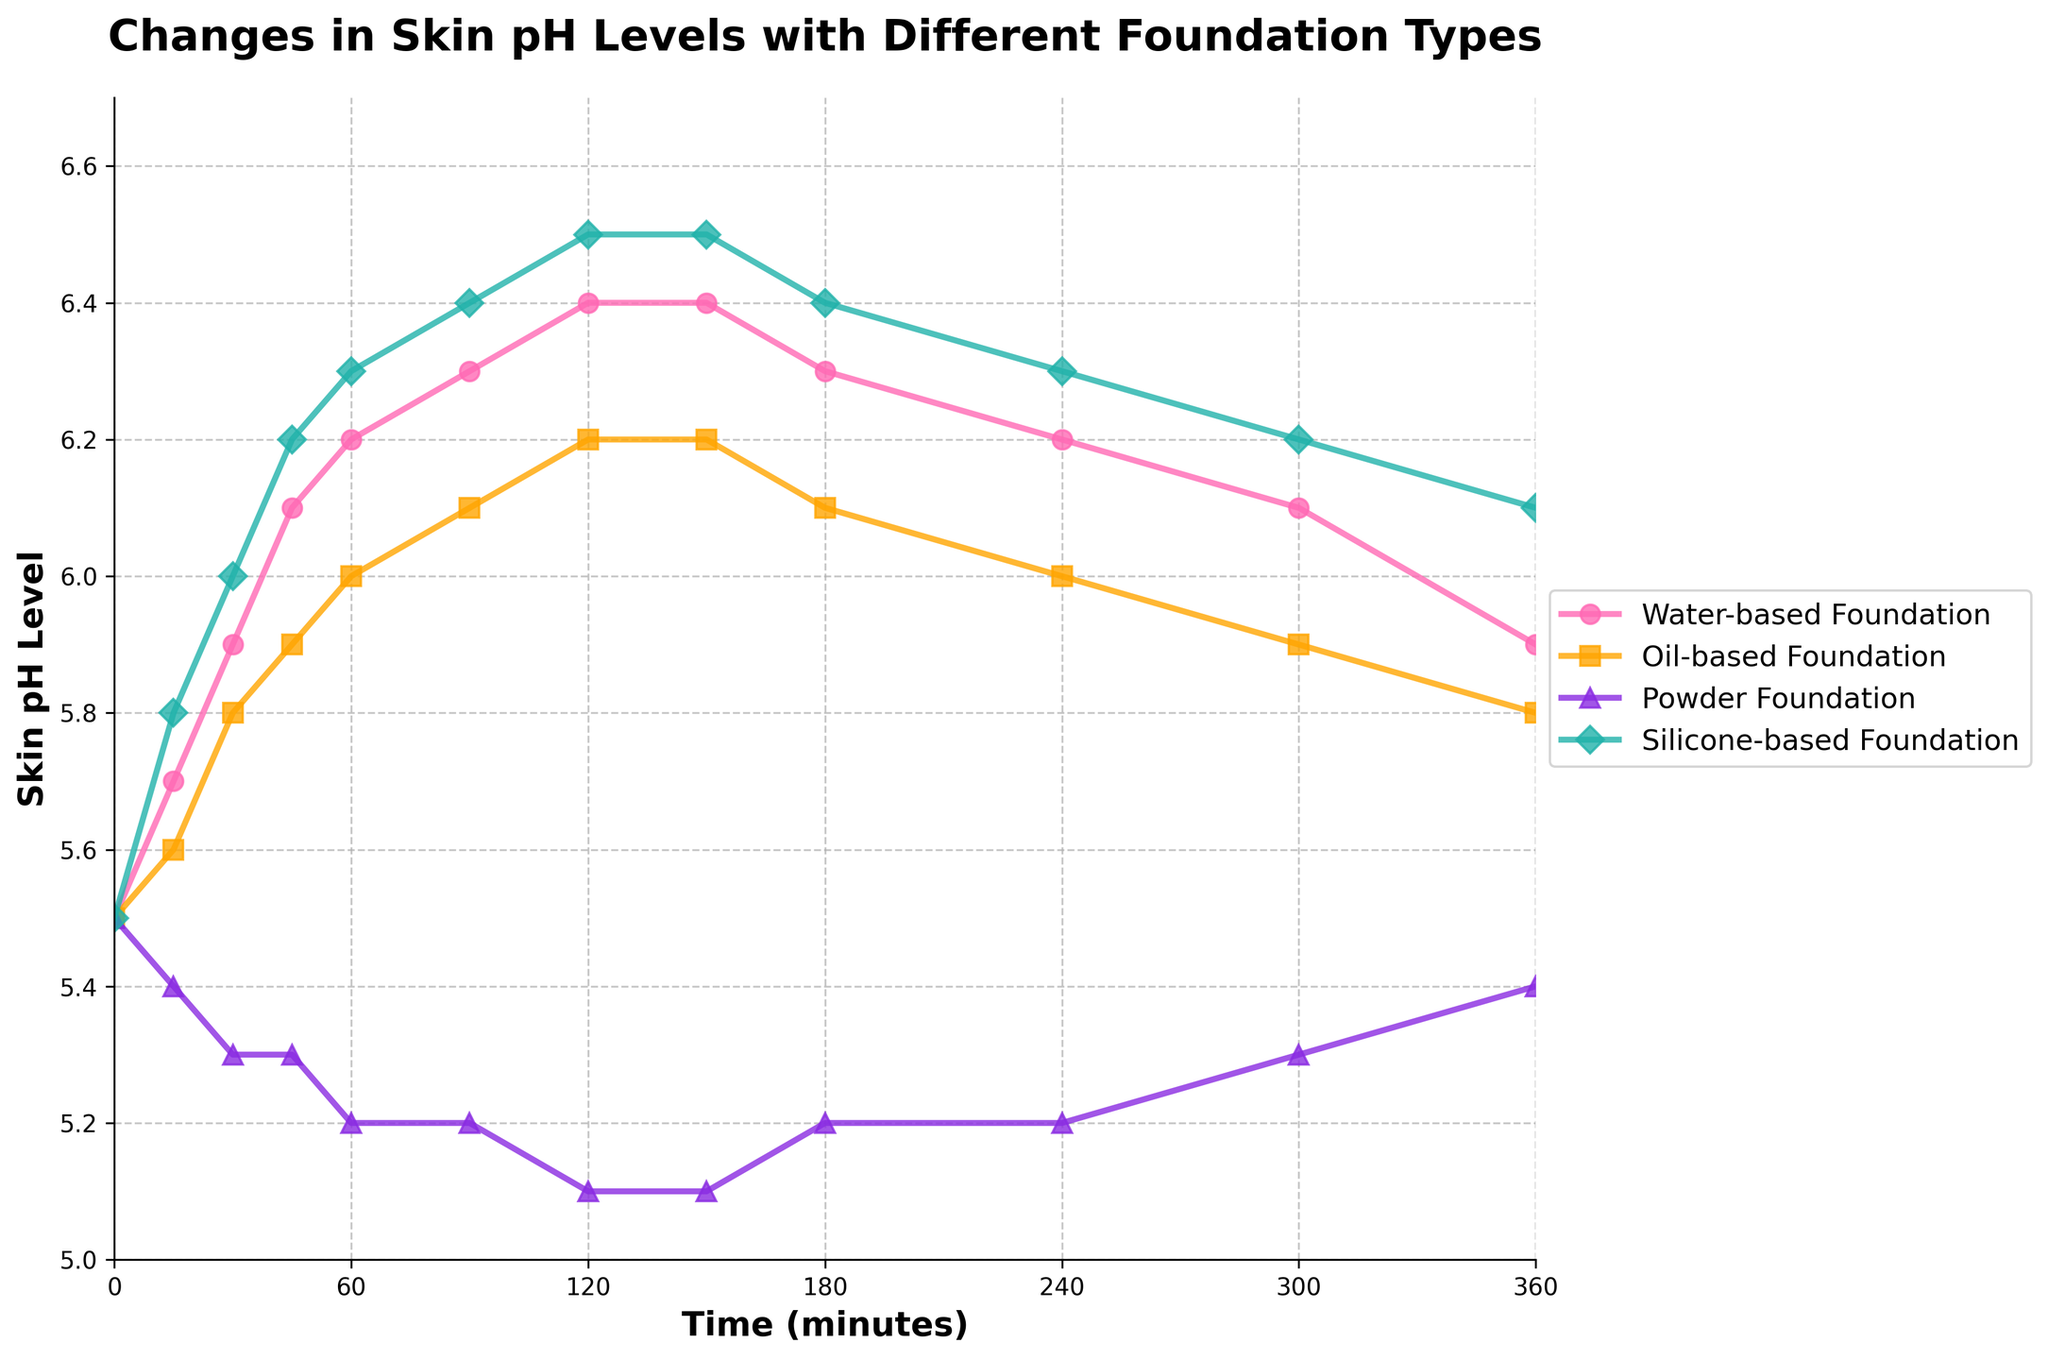What is the overall trend in skin pH levels for the Water-based Foundation over time? The line representing Water-based Foundation starts at a skin pH level of 5.5 at 0 minutes and steadily increases to a peak around 6.4 at 120 minutes, before slightly decreasing back down to 5.9 by 360 minutes. The overall trend is an increase followed by a slight decrease.
Answer: Increase then decrease Which foundation type shows the most significant increase in skin pH levels from 0 to 180 minutes? By comparing the starting and peak points of each foundation type, we see that the Silicone-based Foundation starts at 5.5 and increases to approximately 6.5, which is the most significant increase among the foundations.
Answer: Silicone-based Foundation How does the pH level of Powder Foundation 90 minutes after application compare to its level at 120 minutes? The pH level of Powder Foundation remains consistent at 5.2 between both 90 and 120 minutes, indicating no change during this period.
Answer: No change: 5.2 At what time point do the Water-based Foundation and Oil-based Foundation both show a skin pH level of 6.0? By examining the plot, we see that the Water-based Foundation shows a pH level of 6.0 at 60 minutes and the Oil-based Foundation reaches a pH level of 6.0 at 120 minutes.
Answer: 60 minutes for Water-based, 120 minutes for Oil-based Which foundation type demonstrates the smallest variation in skin pH levels over the entire time period? Observing the vertical spread of data points, the Powder Foundation shows the smallest variation, starting at 5.5 and only fluctuating between 5.1 and 5.4.
Answer: Powder Foundation What is the visual distinction between the different foundation lines on the plot? Each foundation type is represented by a different color and marker; Water-based is pink with circular markers, Oil-based is orange with square markers, Powder is purple with triangular markers, and Silicone-based is light blue with diamond markers.
Answer: Different colors and markers By how much does the pH level of Oil-based Foundation change from 0 to 360 minutes? The pH level for Oil-based Foundation starts at 5.5 and ends at 5.8, thereby increasing by 0.3 units over 360 minutes.
Answer: Increase by 0.3 units What is the pH level range for the Silicone-based Foundation within the first 240 minutes? The Silicone-based Foundation starts at 5.5 and reaches up to 6.5 towards 240 minutes, making the range 5.5 to 6.5.
Answer: Range: 5.5 to 6.5 At 150 minutes, which foundation type has the highest pH level? According to the plotted data, the Silicone-based Foundation has the highest pH level of approximately 6.5 at 150 minutes.
Answer: Silicone-based Foundation 